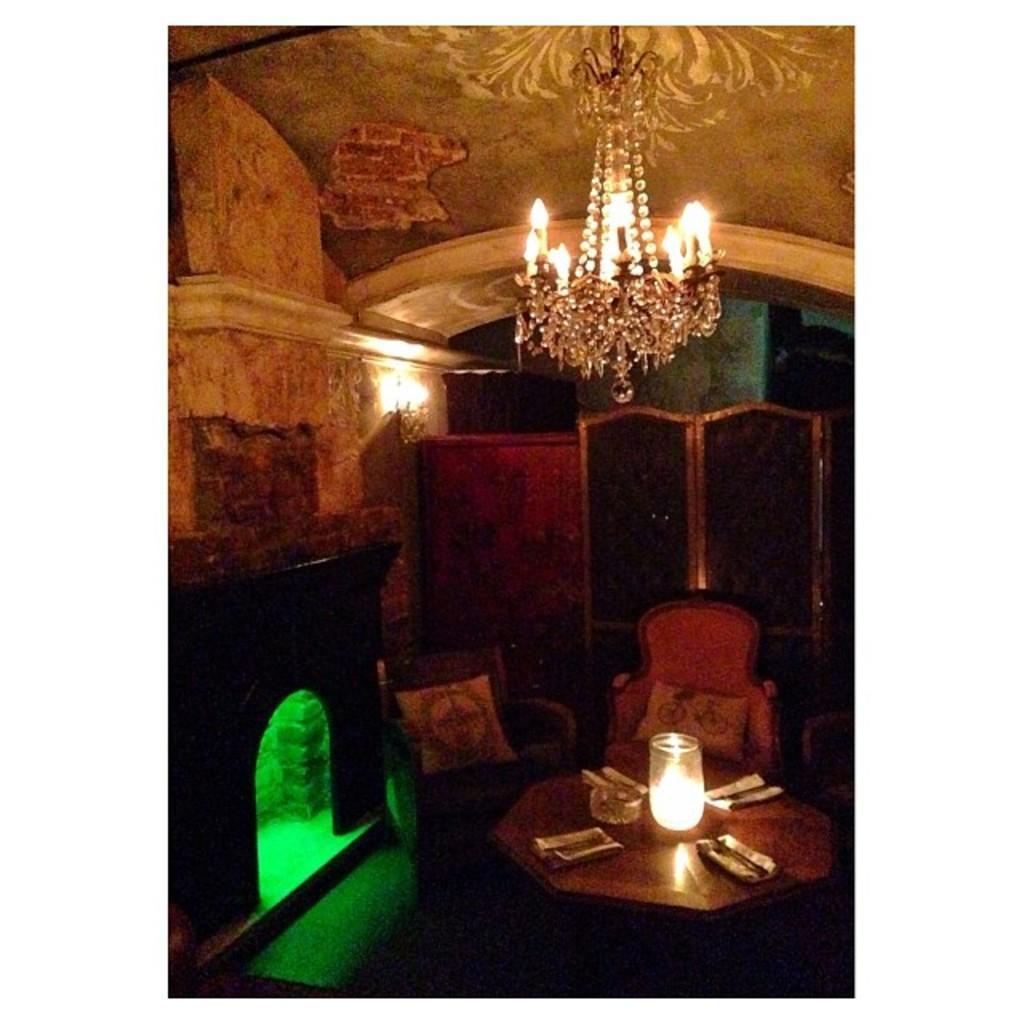Describe this image in one or two sentences. This image is taken from inside. In this image there is a fireplace, in front of it there is a table. On the table there is a lamp and some other objects and there are two chairs. In the background there is a wooden wall. At the top of the image there is a chandelier hanging from the ceiling. 